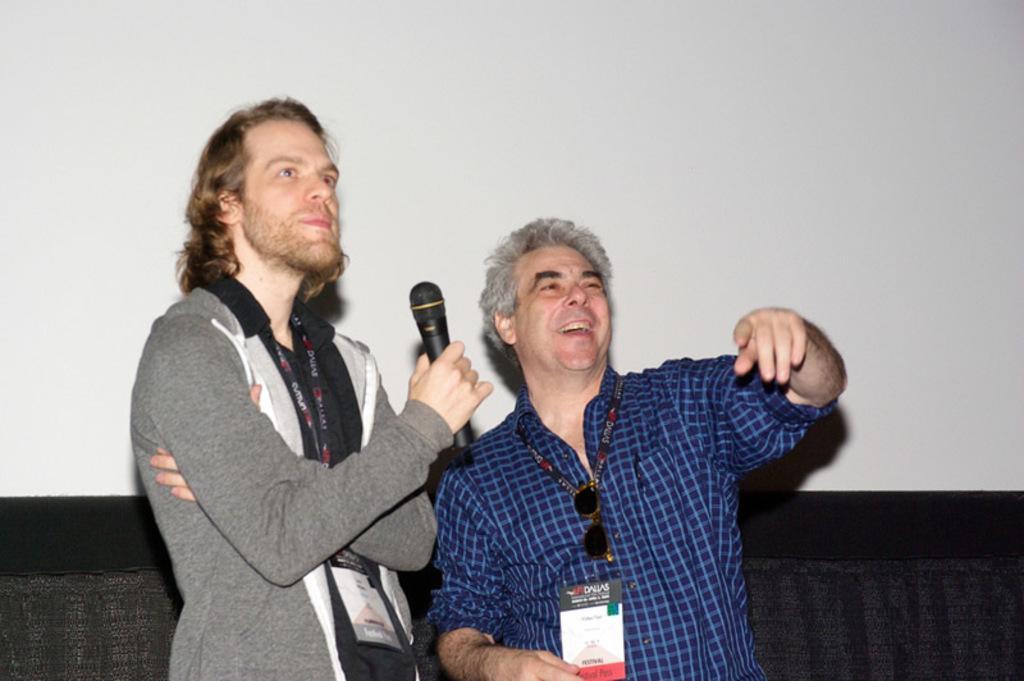Describe this image in one or two sentences. This picture shows two people with a smile on their faces and a person holds a microphone. 